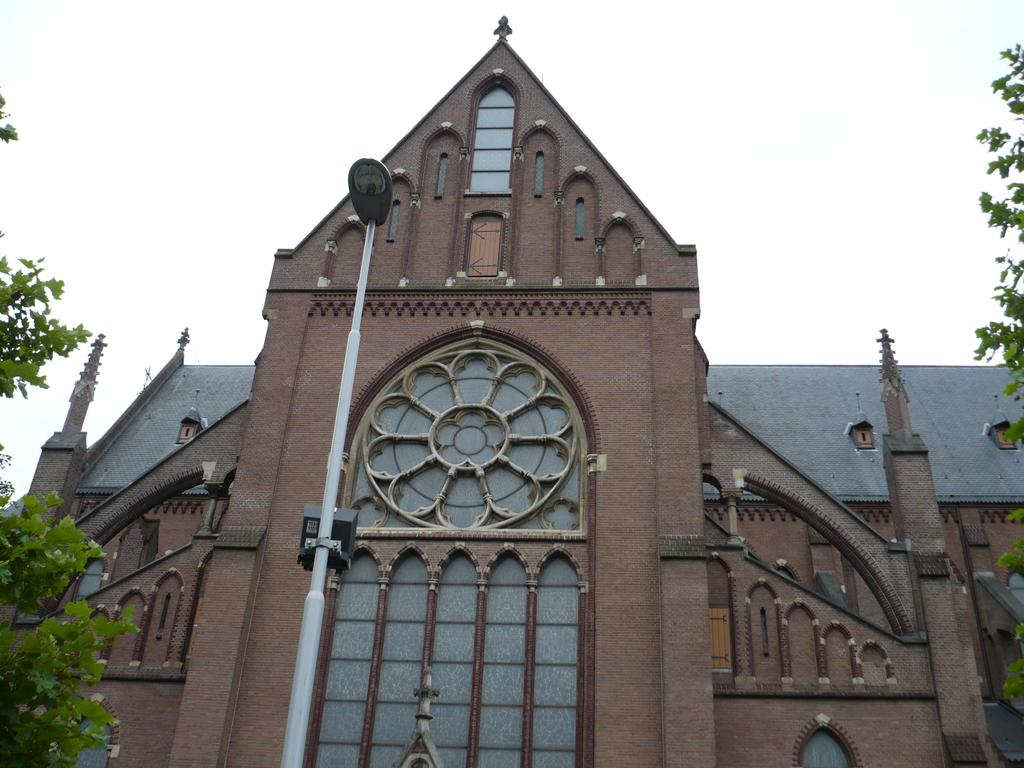What type of structure is present in the image? There is a building in the image. What else can be seen in the image besides the building? There is a pole and trees visible in the image. What is visible at the top of the image? The sky is visible at the top of the image. What is the opinion of the trees about the building in the image? Trees do not have opinions, as they are inanimate objects. 